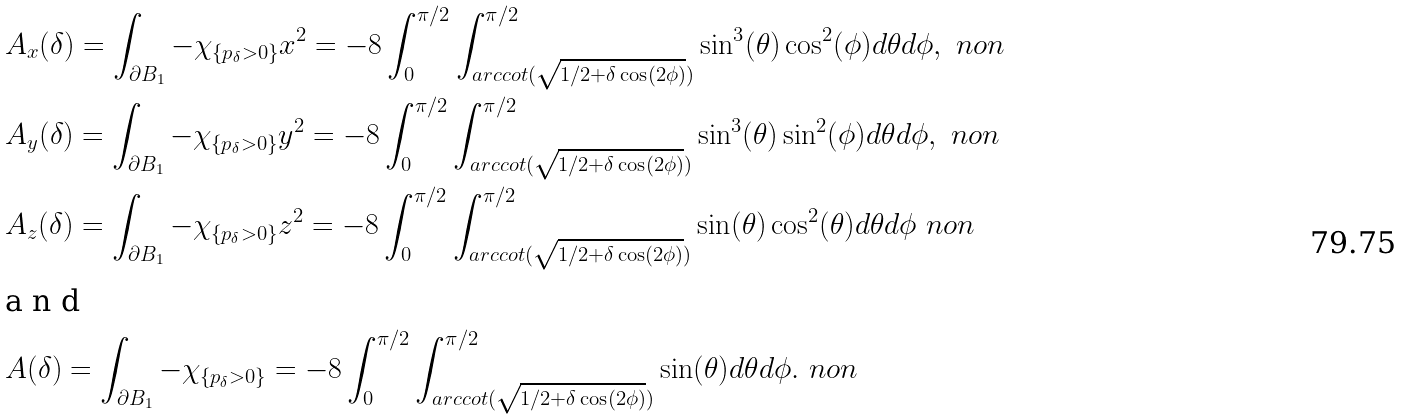<formula> <loc_0><loc_0><loc_500><loc_500>& A _ { x } ( \delta ) = \int _ { \partial B _ { 1 } } - \chi _ { \{ p _ { \delta } > 0 \} } x ^ { 2 } = - 8 \int _ { 0 } ^ { \pi / 2 } \int _ { a r c c o t ( \sqrt { 1 / 2 + \delta \cos ( 2 \phi ) } ) } ^ { \pi / 2 } \sin ^ { 3 } ( \theta ) \cos ^ { 2 } ( \phi ) d \theta d \phi , \ n o n \\ & A _ { y } ( \delta ) = \int _ { \partial B _ { 1 } } - \chi _ { \{ p _ { \delta } > 0 \} } y ^ { 2 } = - 8 \int _ { 0 } ^ { \pi / 2 } \int _ { a r c c o t ( \sqrt { 1 / 2 + \delta \cos ( 2 \phi ) } ) } ^ { \pi / 2 } \sin ^ { 3 } ( \theta ) \sin ^ { 2 } ( \phi ) d \theta d \phi , \ n o n \\ & A _ { z } ( \delta ) = \int _ { \partial B _ { 1 } } - \chi _ { \{ p _ { \delta } > 0 \} } z ^ { 2 } = - 8 \int _ { 0 } ^ { \pi / 2 } \int _ { a r c c o t ( \sqrt { 1 / 2 + \delta \cos ( 2 \phi ) } ) } ^ { \pi / 2 } \sin ( \theta ) \cos ^ { 2 } ( \theta ) d \theta d \phi \ n o n \\ \intertext { a n d } & A ( \delta ) = \int _ { \partial B _ { 1 } } - \chi _ { \{ p _ { \delta } > 0 \} } = - 8 \int _ { 0 } ^ { \pi / 2 } \int _ { a r c c o t ( \sqrt { 1 / 2 + \delta \cos ( 2 \phi ) } ) } ^ { \pi / 2 } \sin ( \theta ) d \theta d \phi . \ n o n</formula> 